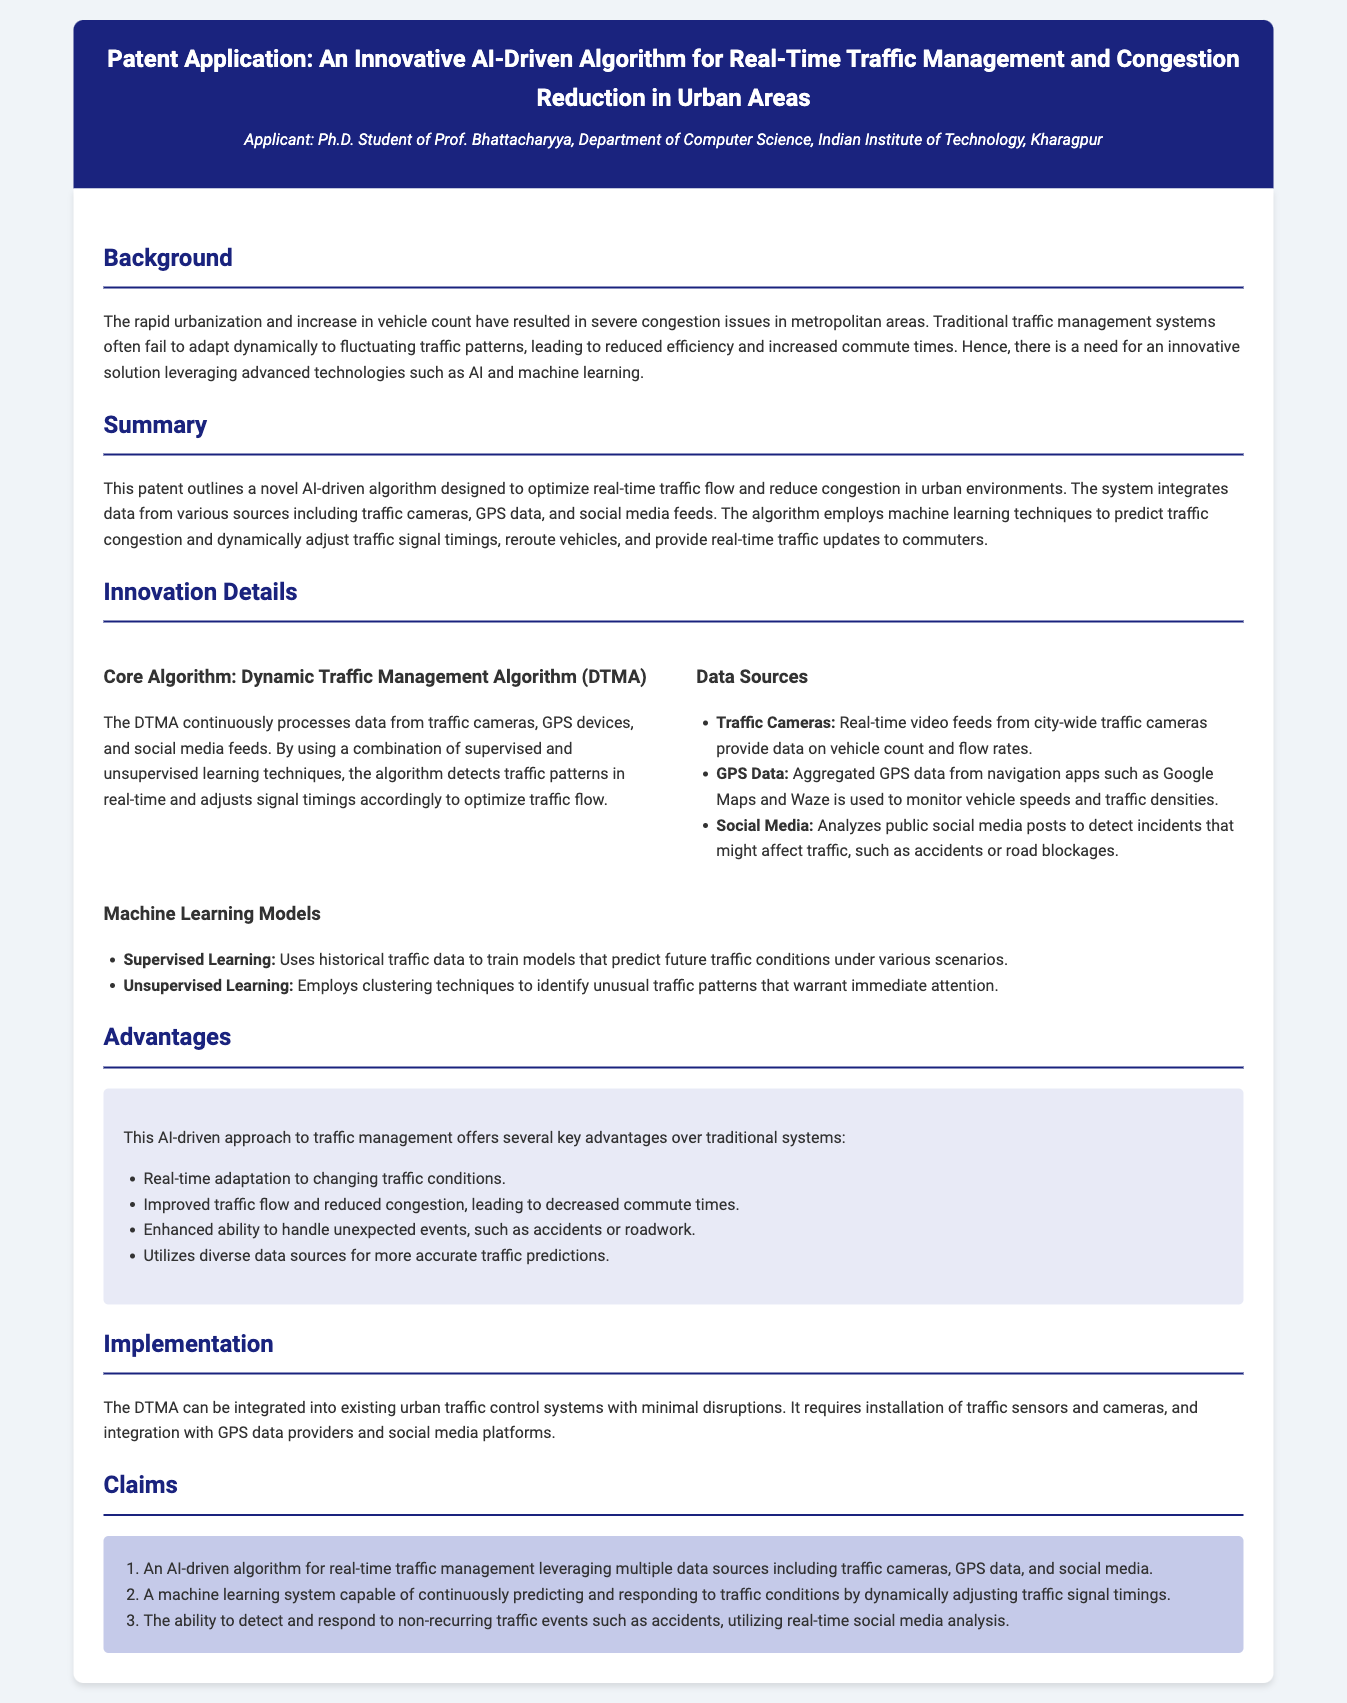what is the title of the patent application? The title is stated in the document header, which describes the essence of the invention.
Answer: An Innovative AI-Driven Algorithm for Real-Time Traffic Management and Congestion Reduction in Urban Areas who is the applicant of the patent? The applicant is mentioned in the header of the document, indicating their affiliation.
Answer: Ph.D. Student of Prof. Bhattacharyya, Department of Computer Science, Indian Institute of Technology, Kharagpur what problem does the innovative algorithm aim to address? The background section highlights the main issue that the algorithm is designed to solve.
Answer: Severe congestion issues in metropolitan areas what are two data sources used in the system? The document outlines the sources of data utilized by the algorithm in the innovation details section.
Answer: Traffic Cameras, GPS Data what type of machine learning does the algorithm utilize? The summary and innovation details sections describe the types of machine learning involved in the algorithm.
Answer: Supervised Learning and Unsupervised Learning what is one key advantage of this AI-driven approach? The advantages section lists several benefits of the proposed approach.
Answer: Real-time adaptation to changing traffic conditions how can the algorithm be integrated into existing systems? The implementation section briefly describes the integration process of the algorithm into current systems.
Answer: Requires installation of traffic sensors and cameras what is the focus of claim number two? Claims are designed to define the scope of the patent; this claim mentions the algorithm's capabilities.
Answer: A machine learning system capable of continuously predicting and responding to traffic conditions by dynamically adjusting traffic signal timings what is the proposed solution for unexpected traffic events? The document explains how the algorithm can handle unplanned events.
Answer: Utilizing real-time social media analysis 